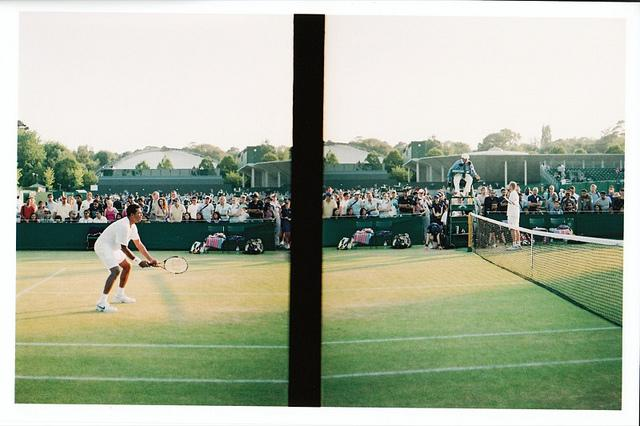Who is the person sitting high above the tennis net?

Choices:
A) referee
B) trainer
C) coach
D) announcer referee 